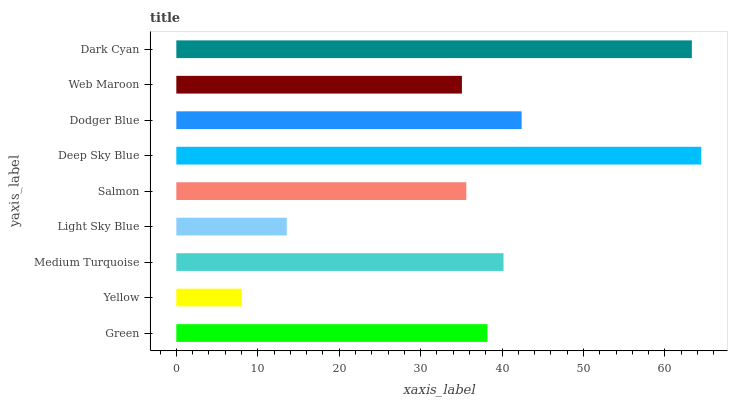Is Yellow the minimum?
Answer yes or no. Yes. Is Deep Sky Blue the maximum?
Answer yes or no. Yes. Is Medium Turquoise the minimum?
Answer yes or no. No. Is Medium Turquoise the maximum?
Answer yes or no. No. Is Medium Turquoise greater than Yellow?
Answer yes or no. Yes. Is Yellow less than Medium Turquoise?
Answer yes or no. Yes. Is Yellow greater than Medium Turquoise?
Answer yes or no. No. Is Medium Turquoise less than Yellow?
Answer yes or no. No. Is Green the high median?
Answer yes or no. Yes. Is Green the low median?
Answer yes or no. Yes. Is Yellow the high median?
Answer yes or no. No. Is Salmon the low median?
Answer yes or no. No. 